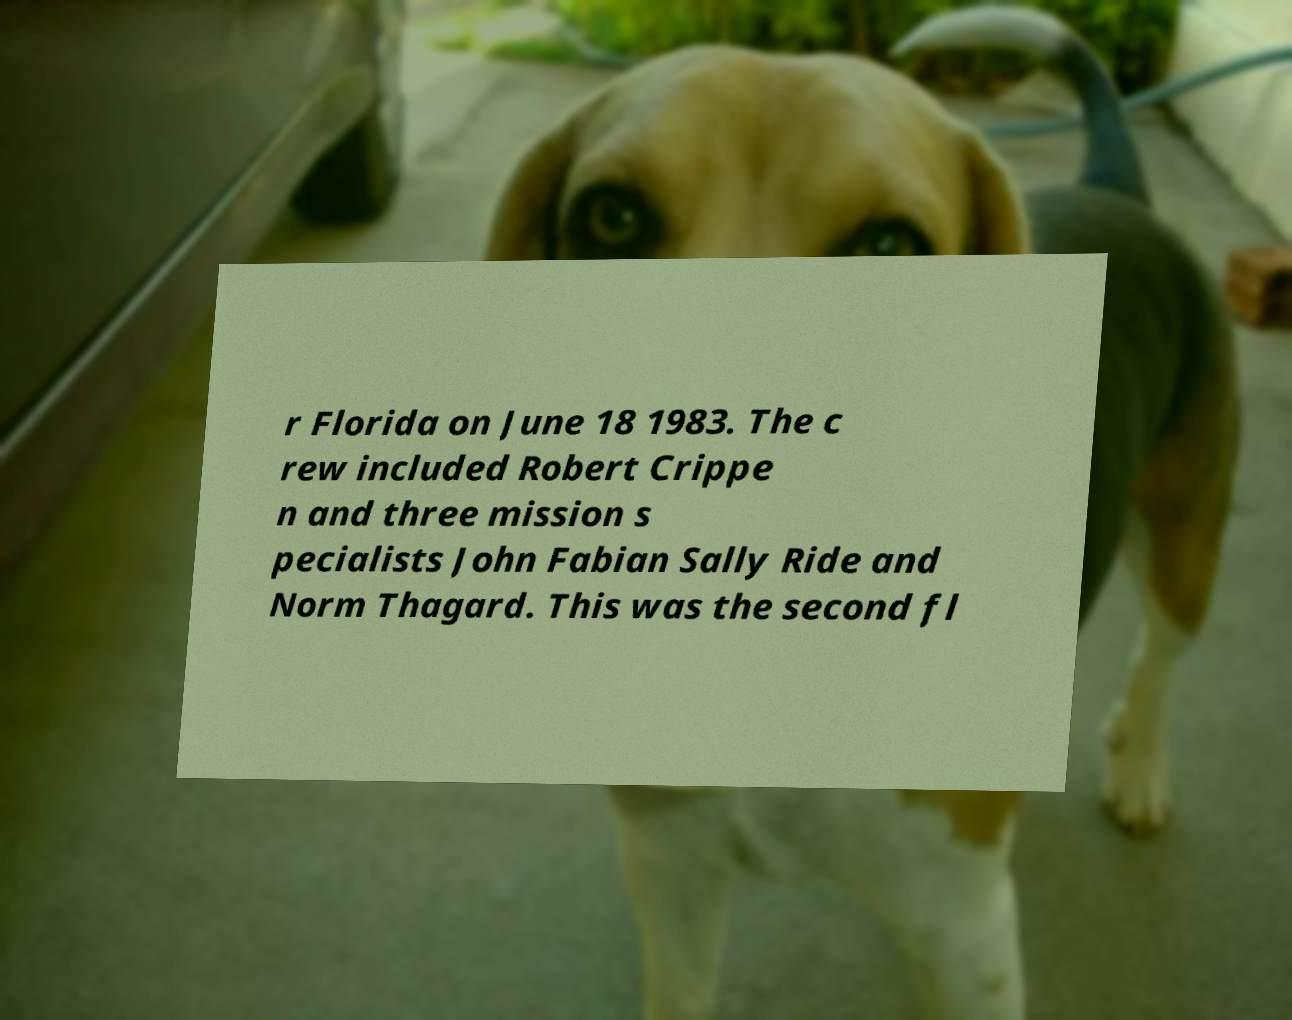There's text embedded in this image that I need extracted. Can you transcribe it verbatim? r Florida on June 18 1983. The c rew included Robert Crippe n and three mission s pecialists John Fabian Sally Ride and Norm Thagard. This was the second fl 